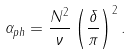<formula> <loc_0><loc_0><loc_500><loc_500>\alpha _ { p h } = \frac { N ^ { 2 } } { \nu } \left ( \frac { \delta } { \pi } \right ) ^ { 2 } .</formula> 